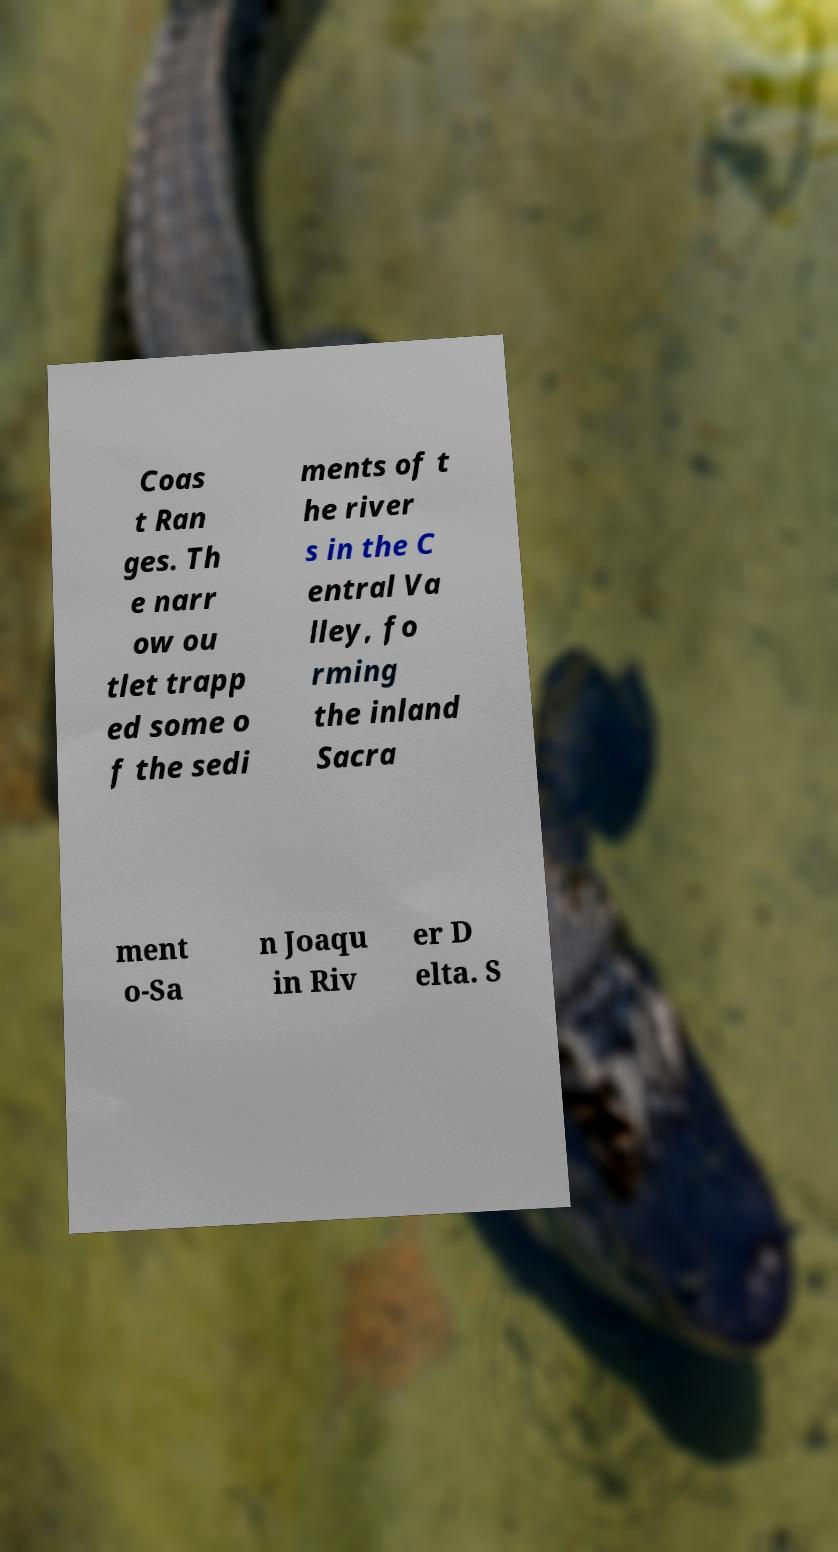Could you extract and type out the text from this image? Coas t Ran ges. Th e narr ow ou tlet trapp ed some o f the sedi ments of t he river s in the C entral Va lley, fo rming the inland Sacra ment o-Sa n Joaqu in Riv er D elta. S 